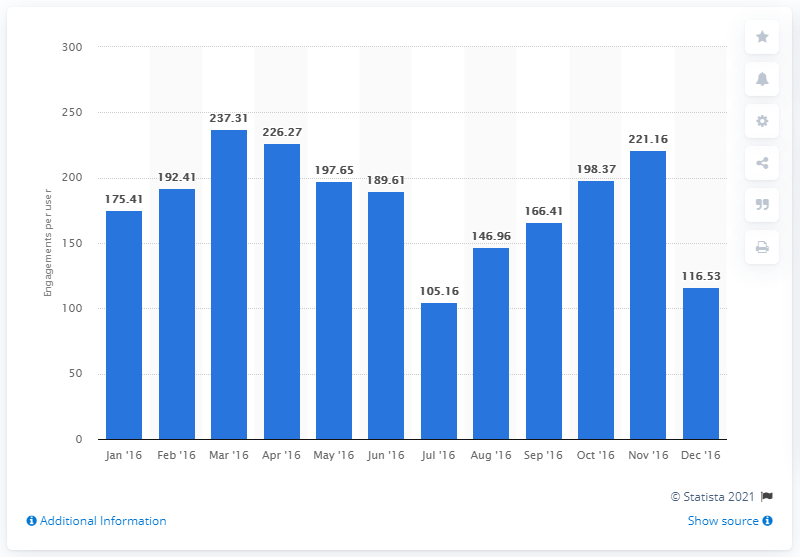Mention a couple of crucial points in this snapshot. The average number of earned content engagements in the previous month was 221.16. 